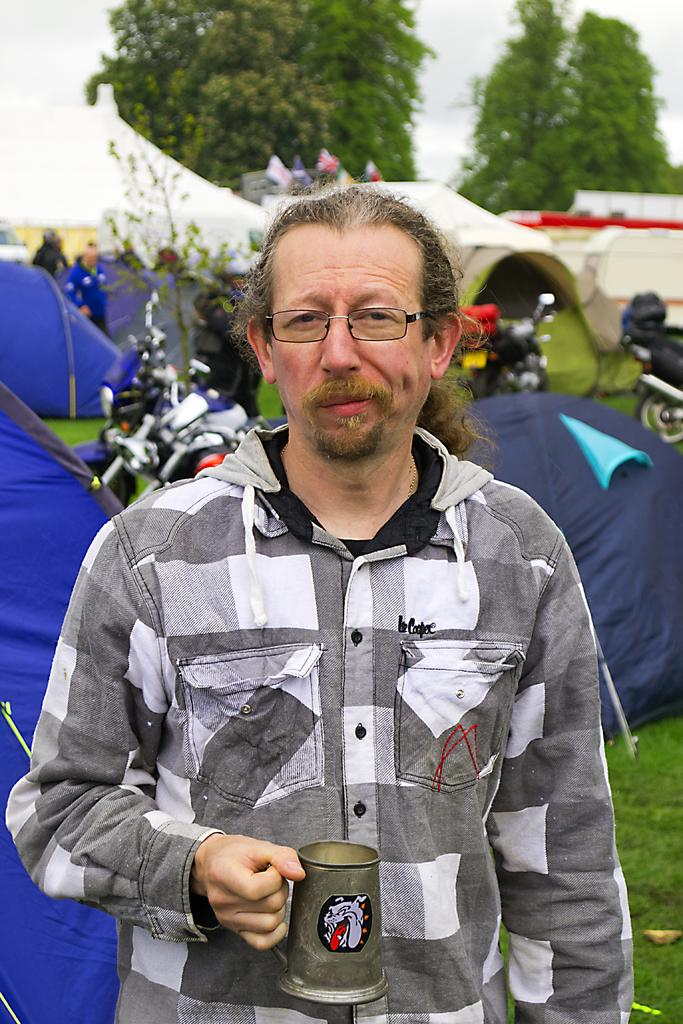What is the person in the image doing? The person is standing in the image and holding a cup. What can be seen in the background of the image? There are tents, motorbikes, trees, and the sky visible in the background of the image. What direction is the sleet falling from in the image? There is no mention of sleet in the image, so it cannot be determined from which direction it would be falling. 